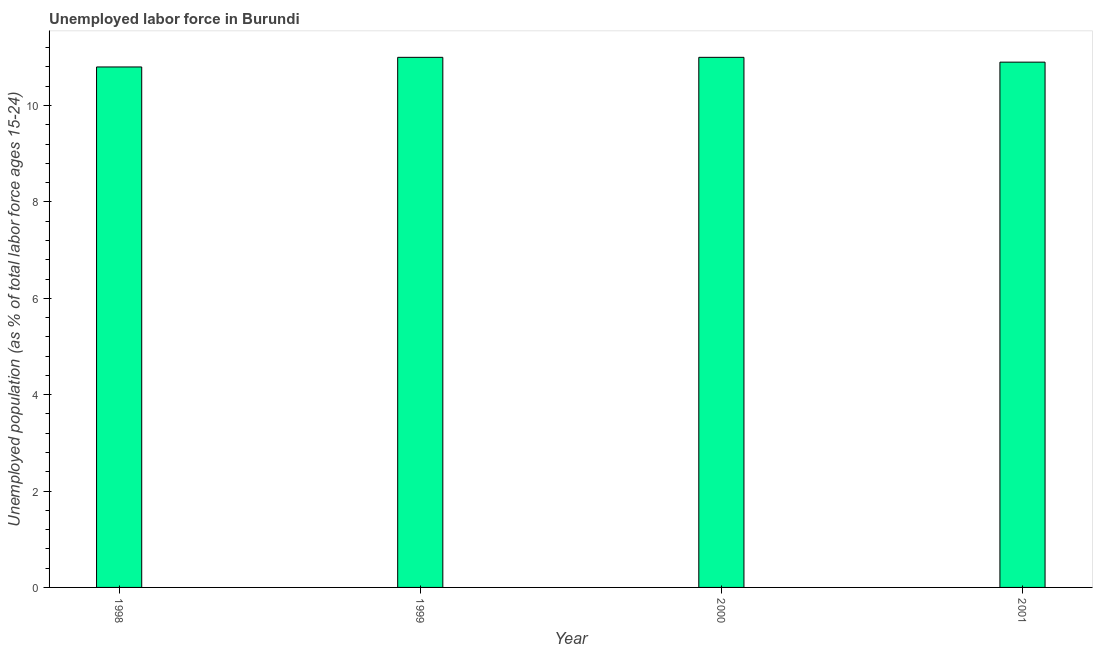Does the graph contain grids?
Keep it short and to the point. No. What is the title of the graph?
Offer a very short reply. Unemployed labor force in Burundi. What is the label or title of the Y-axis?
Your response must be concise. Unemployed population (as % of total labor force ages 15-24). What is the total unemployed youth population in 1998?
Your response must be concise. 10.8. Across all years, what is the maximum total unemployed youth population?
Keep it short and to the point. 11. Across all years, what is the minimum total unemployed youth population?
Keep it short and to the point. 10.8. In which year was the total unemployed youth population minimum?
Provide a succinct answer. 1998. What is the sum of the total unemployed youth population?
Ensure brevity in your answer.  43.7. What is the difference between the total unemployed youth population in 1998 and 2000?
Give a very brief answer. -0.2. What is the average total unemployed youth population per year?
Provide a succinct answer. 10.93. What is the median total unemployed youth population?
Ensure brevity in your answer.  10.95. In how many years, is the total unemployed youth population greater than 10.8 %?
Offer a terse response. 4. Do a majority of the years between 1998 and 2001 (inclusive) have total unemployed youth population greater than 3.2 %?
Provide a succinct answer. Yes. Is the difference between the total unemployed youth population in 1998 and 1999 greater than the difference between any two years?
Your answer should be compact. Yes. What is the difference between the highest and the second highest total unemployed youth population?
Your answer should be very brief. 0. What is the difference between the highest and the lowest total unemployed youth population?
Ensure brevity in your answer.  0.2. How many bars are there?
Keep it short and to the point. 4. Are all the bars in the graph horizontal?
Offer a very short reply. No. How many years are there in the graph?
Offer a very short reply. 4. What is the difference between two consecutive major ticks on the Y-axis?
Your response must be concise. 2. What is the Unemployed population (as % of total labor force ages 15-24) of 1998?
Keep it short and to the point. 10.8. What is the Unemployed population (as % of total labor force ages 15-24) of 1999?
Keep it short and to the point. 11. What is the Unemployed population (as % of total labor force ages 15-24) of 2001?
Provide a succinct answer. 10.9. What is the difference between the Unemployed population (as % of total labor force ages 15-24) in 1998 and 1999?
Your response must be concise. -0.2. What is the difference between the Unemployed population (as % of total labor force ages 15-24) in 1998 and 2000?
Make the answer very short. -0.2. What is the difference between the Unemployed population (as % of total labor force ages 15-24) in 1998 and 2001?
Offer a terse response. -0.1. What is the difference between the Unemployed population (as % of total labor force ages 15-24) in 2000 and 2001?
Your response must be concise. 0.1. What is the ratio of the Unemployed population (as % of total labor force ages 15-24) in 1998 to that in 1999?
Offer a terse response. 0.98. What is the ratio of the Unemployed population (as % of total labor force ages 15-24) in 1998 to that in 2001?
Your answer should be compact. 0.99. 